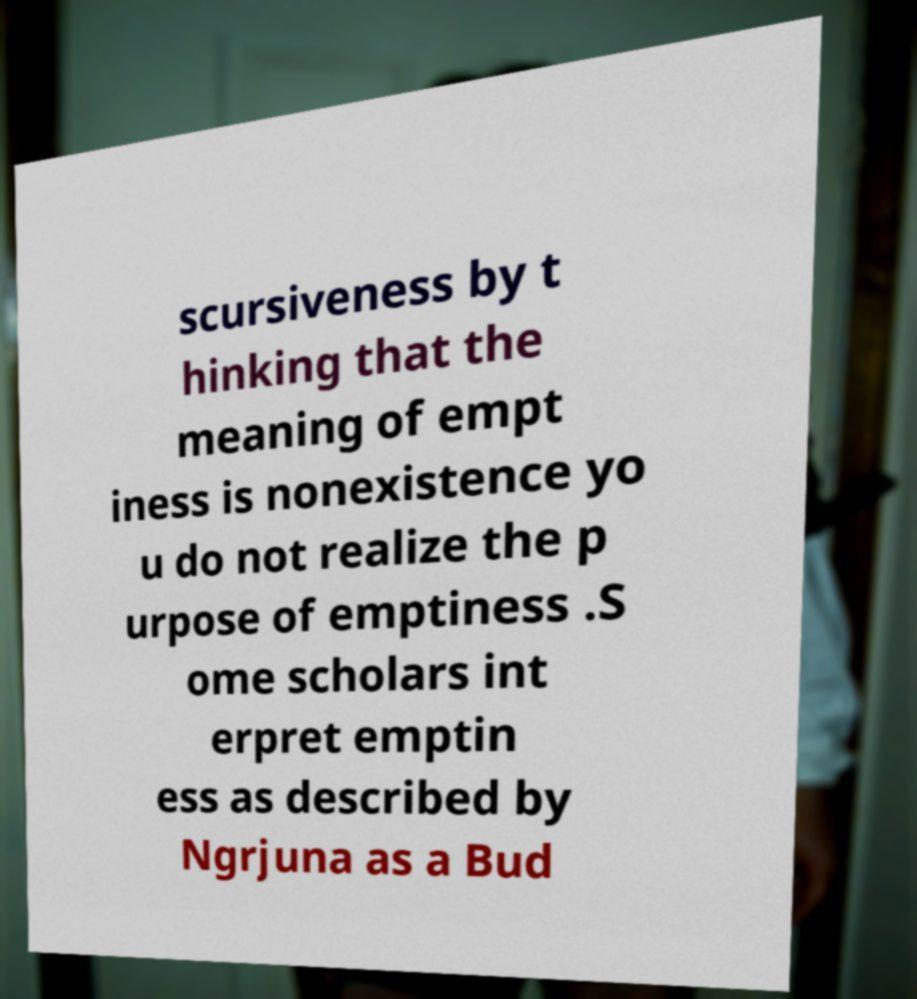Could you extract and type out the text from this image? scursiveness by t hinking that the meaning of empt iness is nonexistence yo u do not realize the p urpose of emptiness .S ome scholars int erpret emptin ess as described by Ngrjuna as a Bud 